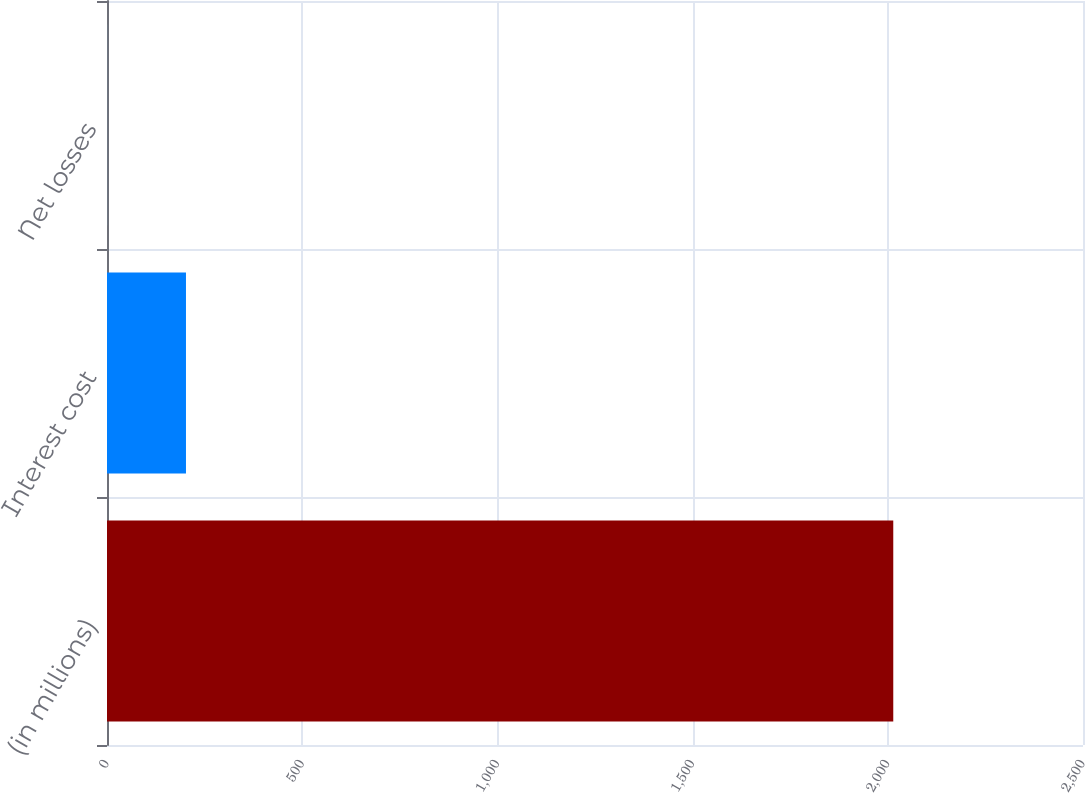Convert chart to OTSL. <chart><loc_0><loc_0><loc_500><loc_500><bar_chart><fcel>(in millions)<fcel>Interest cost<fcel>Net losses<nl><fcel>2014<fcel>202.3<fcel>1<nl></chart> 